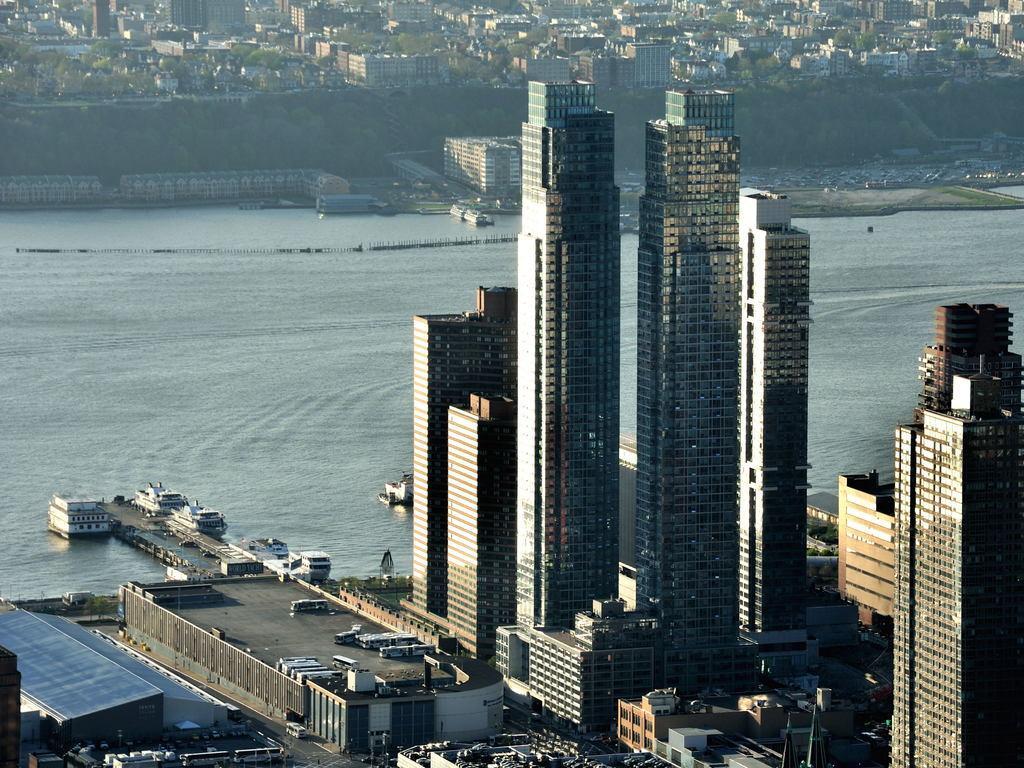How would you summarize this image in a sentence or two? On the right side there are very big buildings, in the middle it is water, there are ships on it. 